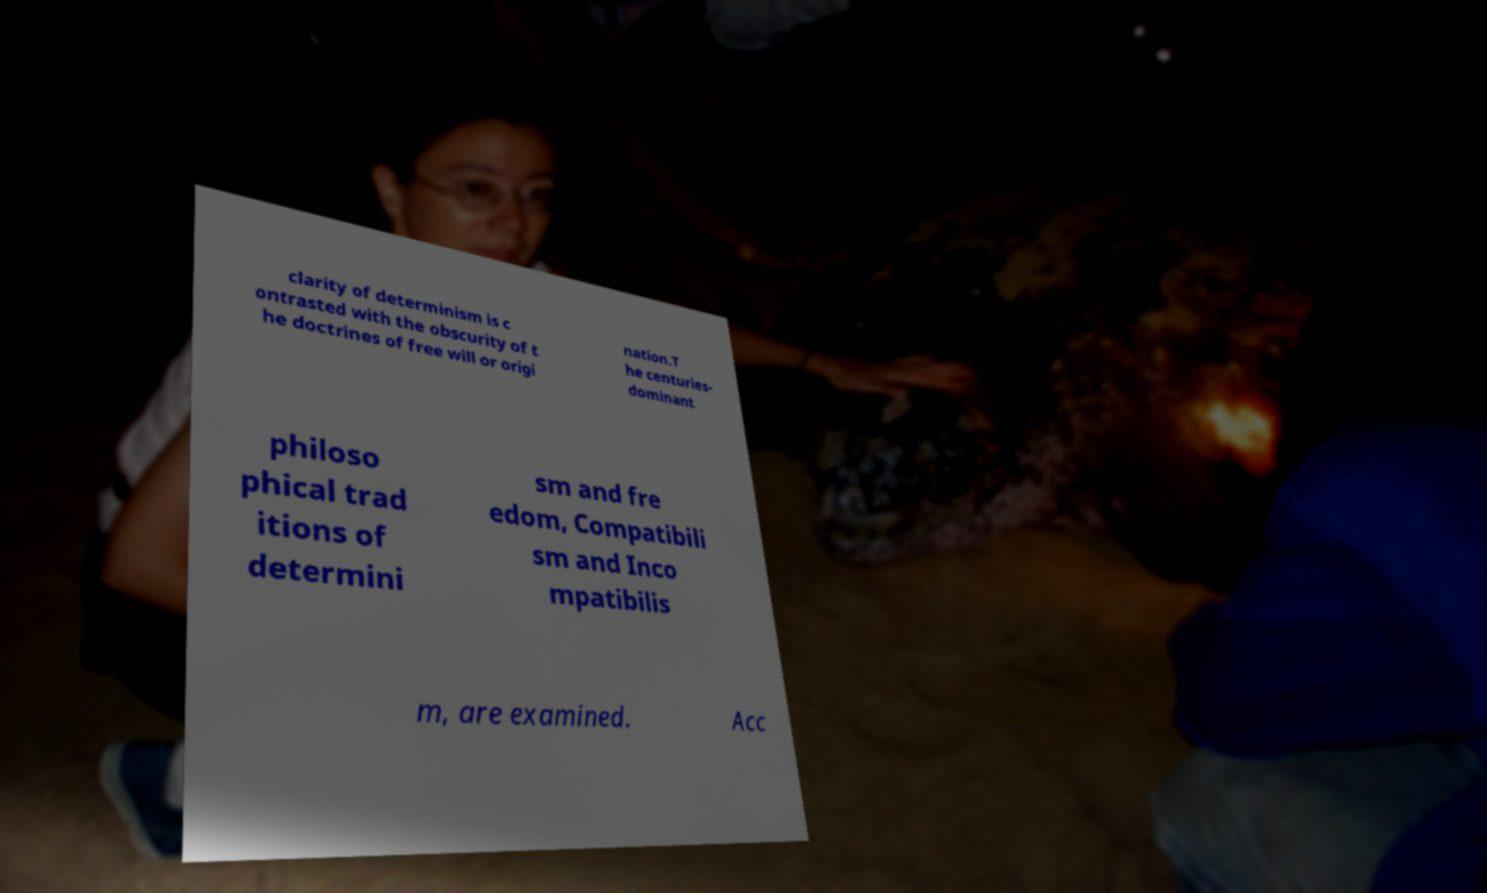Could you extract and type out the text from this image? clarity of determinism is c ontrasted with the obscurity of t he doctrines of free will or origi nation.T he centuries- dominant philoso phical trad itions of determini sm and fre edom, Compatibili sm and Inco mpatibilis m, are examined. Acc 